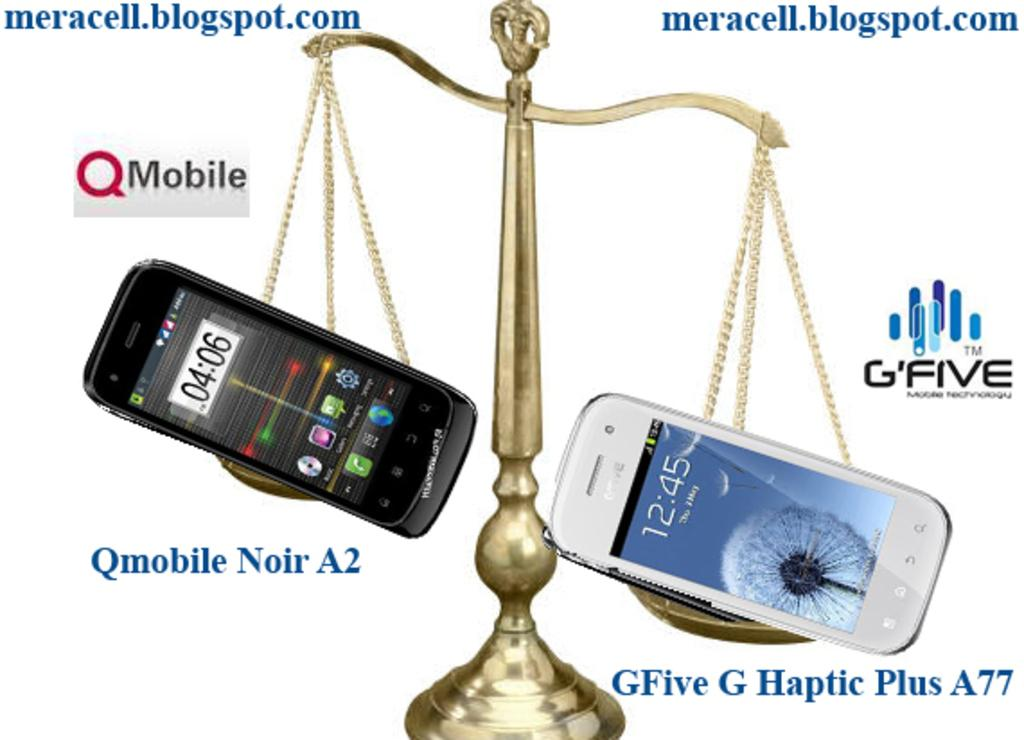<image>
Write a terse but informative summary of the picture. the word five that is on the front of an ad 